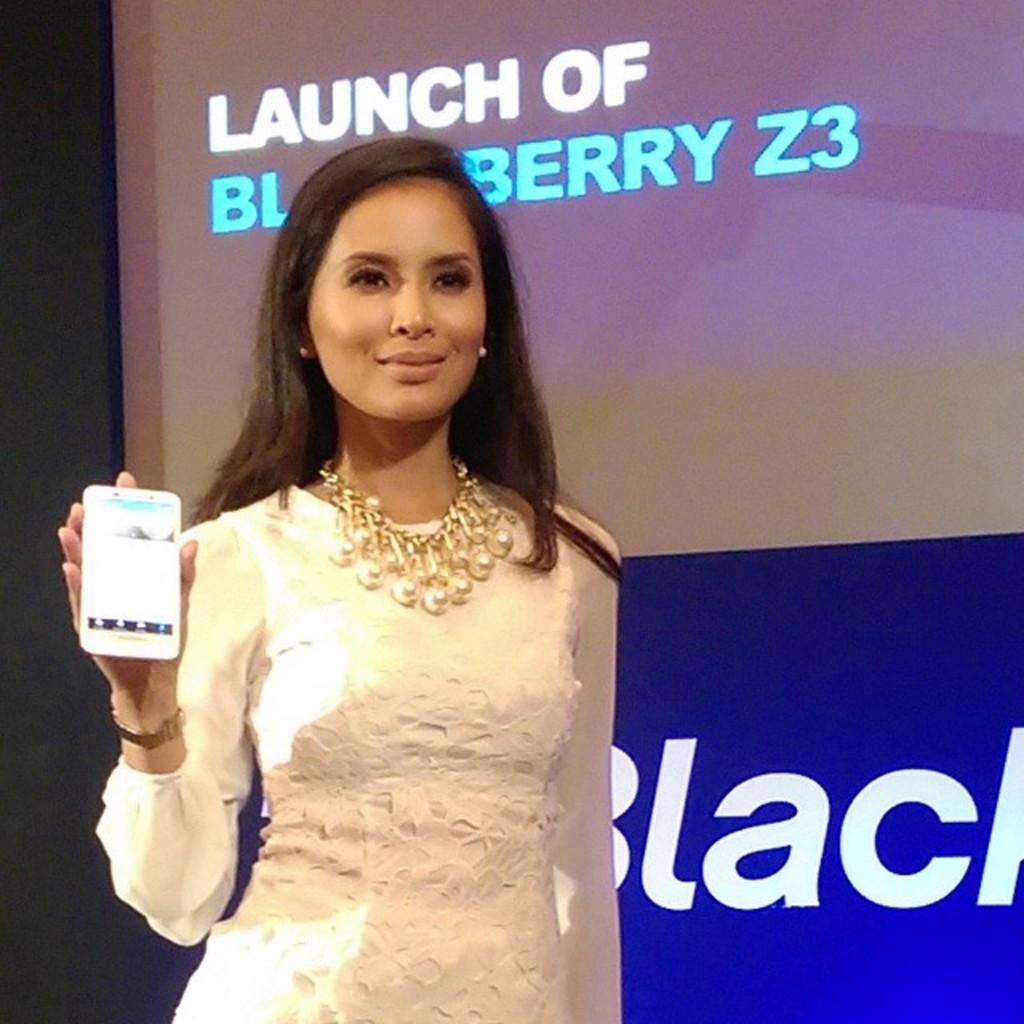Who is present in the image? There is a woman in the image. What is the woman wearing? The woman is wearing a white dress. Can you describe any accessories the woman is wearing? The woman has an ornament on her neck. What is the woman holding in her hand? The woman is holding a mobile phone in her hand. What can be seen in the background of the image? There is a screen in the background of the image. How many ladybugs can be seen on the woman's dress in the image? There are no ladybugs visible on the woman's dress in the image. What discovery was made by the woman in the image? There is no indication of a discovery being made in the image. 